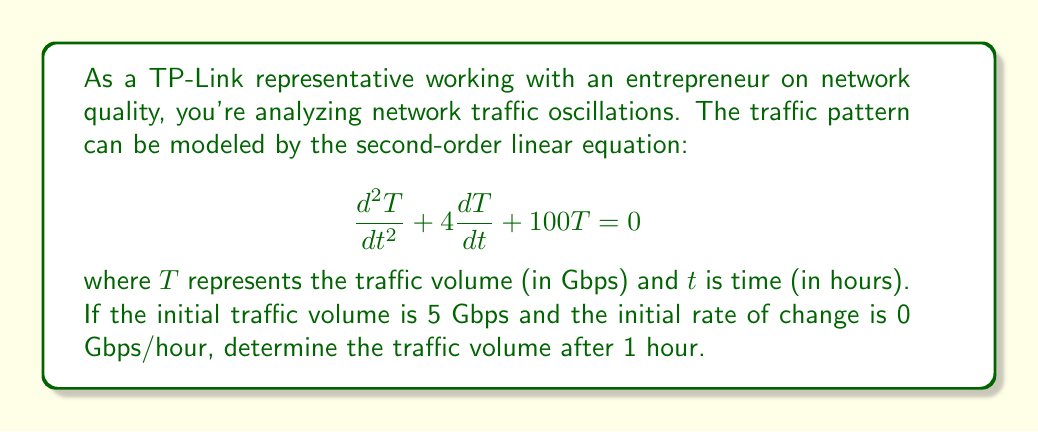Can you solve this math problem? To solve this problem, we need to follow these steps:

1) The general solution for this second-order linear equation is:

   $$T(t) = e^{-2t}(A\cos(8t) + B\sin(8t))$$

   where $A$ and $B$ are constants determined by initial conditions.

2) Given initial conditions:
   $T(0) = 5$ Gbps
   $T'(0) = 0$ Gbps/hour

3) Apply the first condition:
   $$5 = T(0) = e^{-2(0)}(A\cos(0) + B\sin(0)) = A$$

4) For the second condition, differentiate $T(t)$:
   $$T'(t) = -2e^{-2t}(A\cos(8t) + B\sin(8t)) + e^{-2t}(-8A\sin(8t) + 8B\cos(8t))$$

   $$T'(0) = -2A + 8B = 0$$

5) Solve the system of equations:
   $A = 5$
   $-2A + 8B = 0$

   Substituting $A = 5$ in the second equation:
   $-10 + 8B = 0$
   $B = \frac{10}{8} = \frac{5}{4}$

6) The specific solution is:
   $$T(t) = e^{-2t}(5\cos(8t) + \frac{5}{4}\sin(8t))$$

7) Evaluate at $t = 1$:
   $$T(1) = e^{-2}(5\cos(8) + \frac{5}{4}\sin(8))$$

8) Calculate the result:
   $$T(1) \approx 0.1353 \text{ Gbps}$$
Answer: The traffic volume after 1 hour is approximately 0.1353 Gbps. 